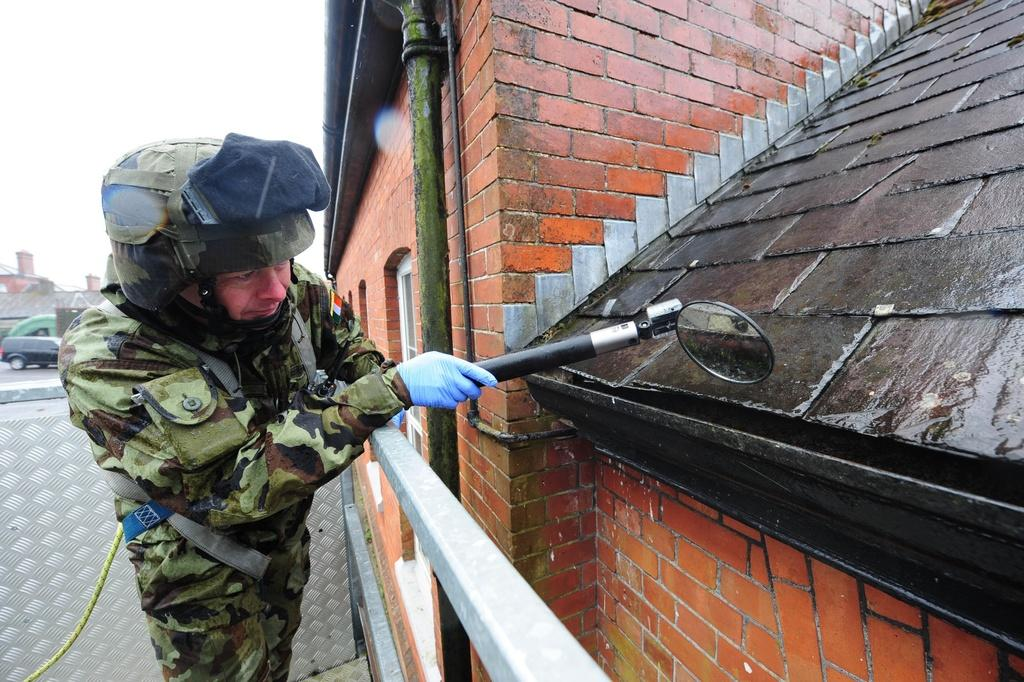What type of structure is visible in the image? There is a house in the image. Can you describe the person in the image? The person is in the middle of the image and is wearing a helmet. What is the person doing in the image? The person is doing something, but we cannot determine the specific action from the provided facts. What is located on the left side of the image? There is a car on the left side of the image. How many screws are visible on the person's helmet in the image? There is no mention of screws on the person's helmet in the image, so we cannot determine the number of screws. What type of stitch is used to sew the person's clothing in the image? There is no information about the person's clothing or the type of stitch used in the image. 